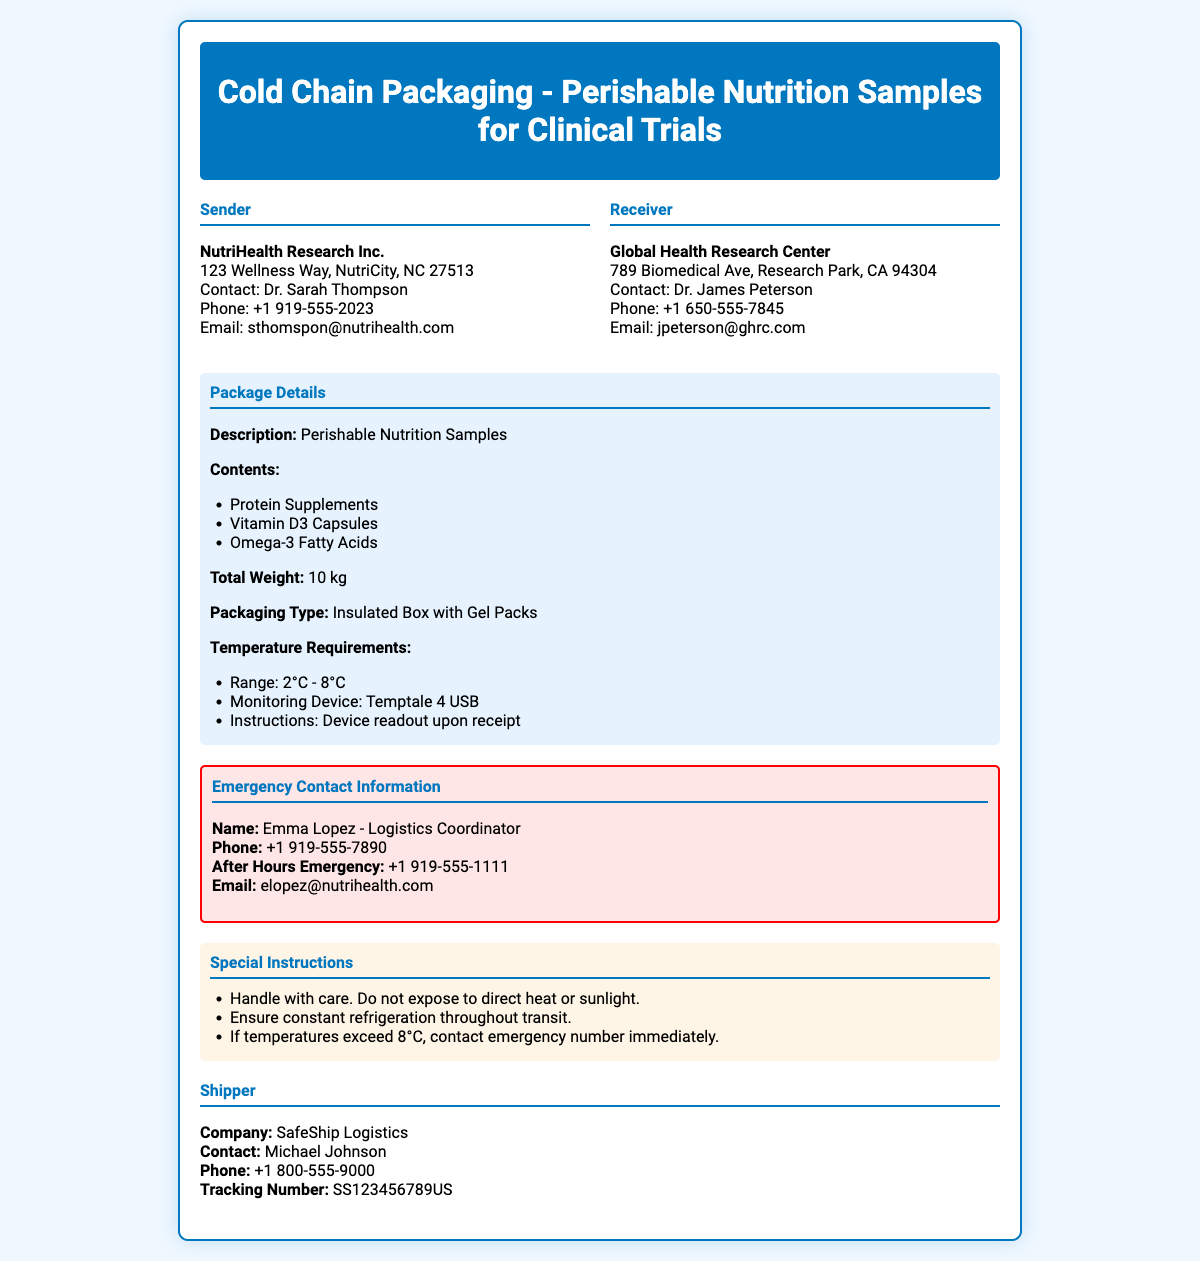What is the sender's name? The sender's name is provided in the document, listed under the sender section as NutriHealth Research Inc.
Answer: NutriHealth Research Inc What is the total weight of the package? The total weight is specified in the package details section of the document.
Answer: 10 kg What is the temperature range required for the nutrition samples? The required temperature range is detailed in the package details section.
Answer: 2°C - 8°C Who is the emergency contact person? The emergency contact person is listed in the emergency contact information section of the document.
Answer: Emma Lopez What is the contact number for after-hours emergencies? The after-hours emergency contact number is provided in the emergency contact information section.
Answer: +1 919-555-1111 What type of packaging is used for the samples? The type of packaging is mentioned in the package details of the document.
Answer: Insulated Box with Gel Packs What should be done if temperatures exceed 8°C? Instructions for exceeding temperatures are included in the special instructions section of the document.
Answer: Contact emergency number immediately What is the email address for the receiver? The email address for the receiver is stated in the receiver section of the document.
Answer: jpeterson@ghrc.com Who is the shipper? The shipper's information is listed in the shipper section of the document.
Answer: SafeShip Logistics 